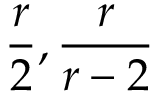<formula> <loc_0><loc_0><loc_500><loc_500>\frac { r } { 2 } , \frac { r } { r - 2 }</formula> 